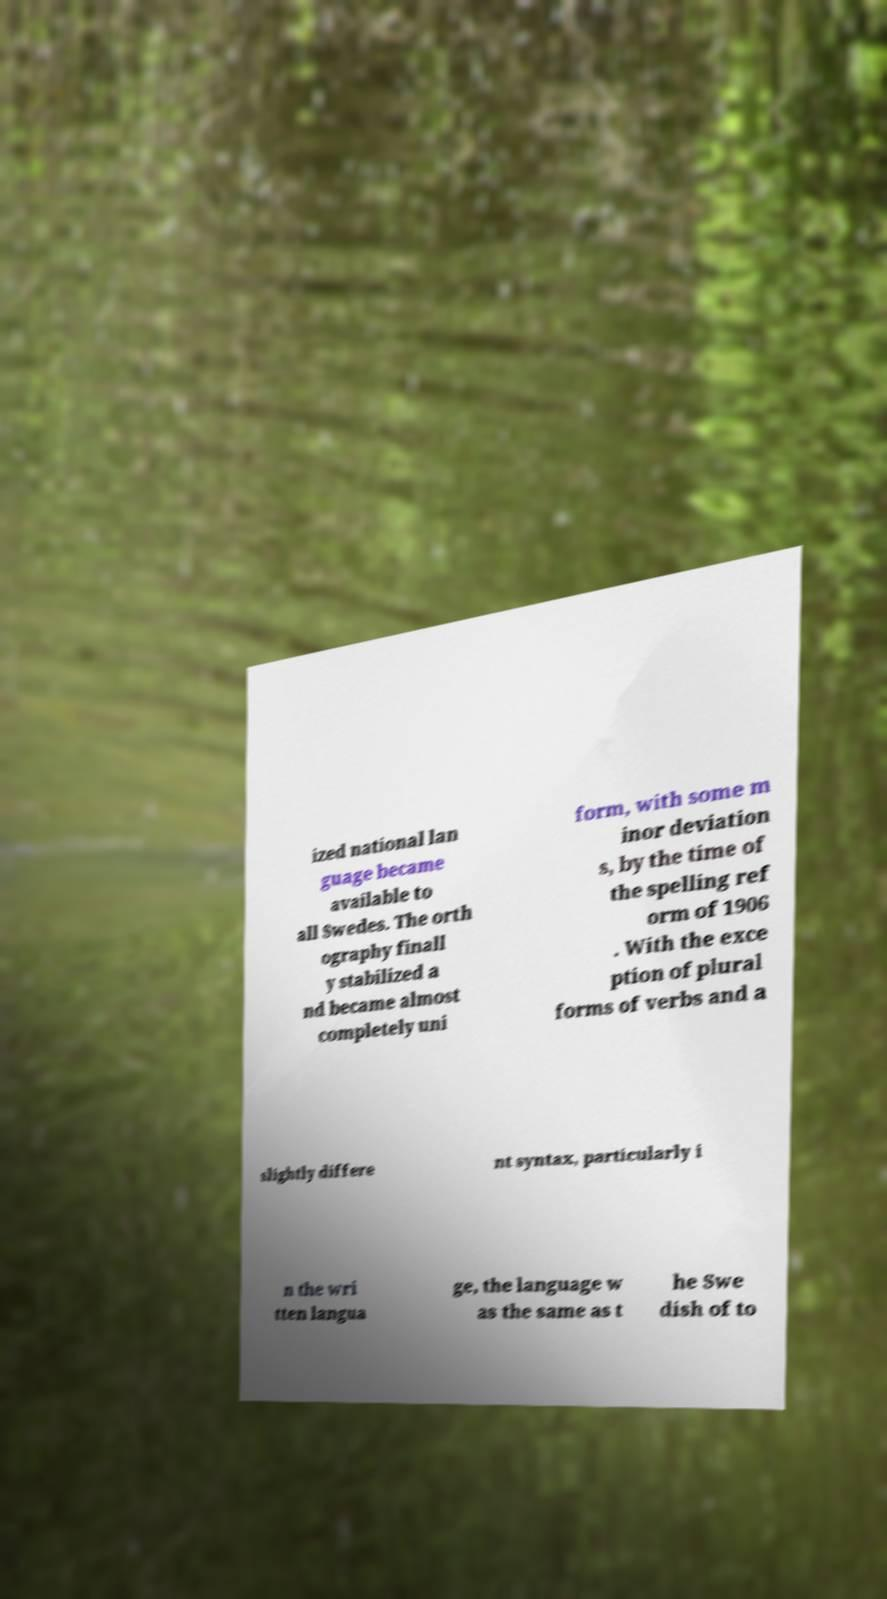Could you assist in decoding the text presented in this image and type it out clearly? ized national lan guage became available to all Swedes. The orth ography finall y stabilized a nd became almost completely uni form, with some m inor deviation s, by the time of the spelling ref orm of 1906 . With the exce ption of plural forms of verbs and a slightly differe nt syntax, particularly i n the wri tten langua ge, the language w as the same as t he Swe dish of to 